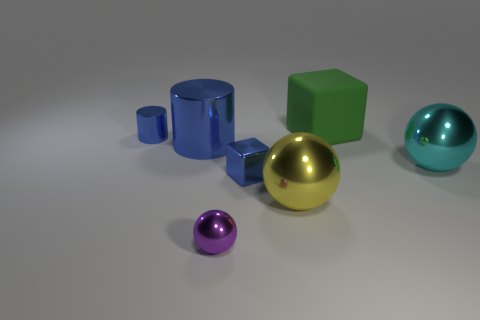Is there anything else that has the same material as the green object?
Keep it short and to the point. No. Are there more small blue metal cubes than big cyan cylinders?
Offer a terse response. Yes. Are there any small blue things right of the small object that is in front of the small shiny object that is to the right of the purple object?
Ensure brevity in your answer.  Yes. How many other things are there of the same size as the green thing?
Provide a short and direct response. 3. There is a big cube; are there any cylinders in front of it?
Ensure brevity in your answer.  Yes. Is the color of the small block the same as the metal cylinder that is right of the tiny blue metallic cylinder?
Your response must be concise. Yes. There is a small thing that is behind the ball to the right of the big shiny ball that is to the left of the rubber thing; what color is it?
Your answer should be very brief. Blue. Is there a shiny thing of the same shape as the matte thing?
Give a very brief answer. Yes. There is a metal cylinder that is the same size as the green rubber block; what is its color?
Offer a very short reply. Blue. What is the cube to the right of the big yellow metallic sphere made of?
Ensure brevity in your answer.  Rubber. 